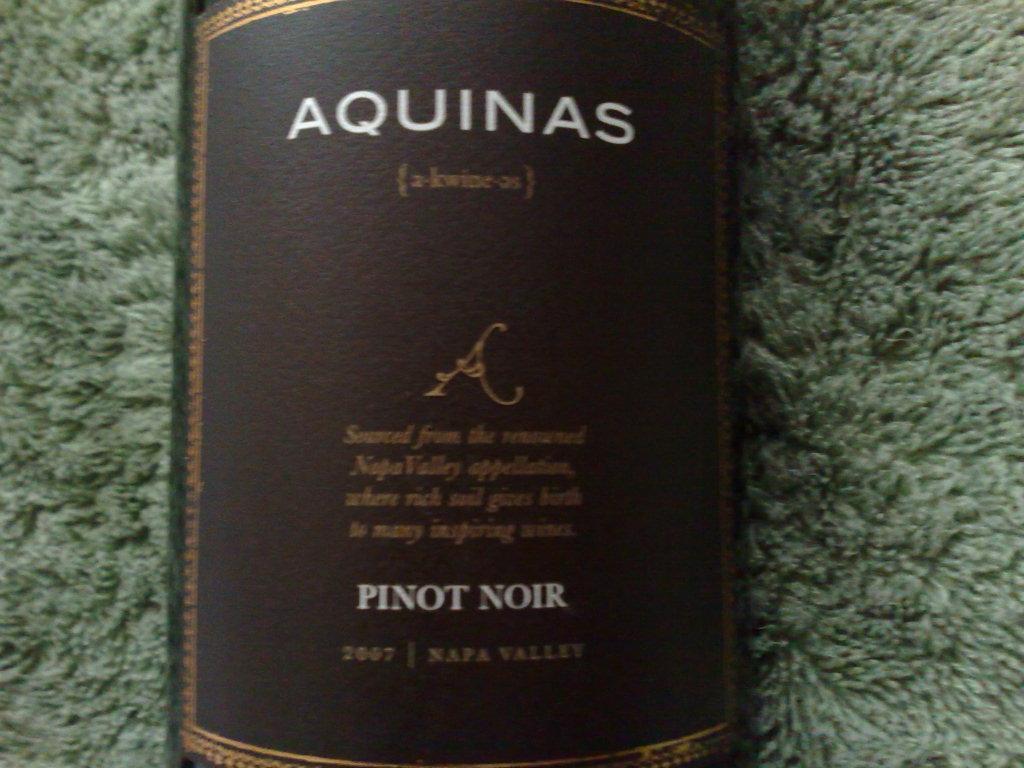What year is this wine from?
Your answer should be very brief. 2007. 